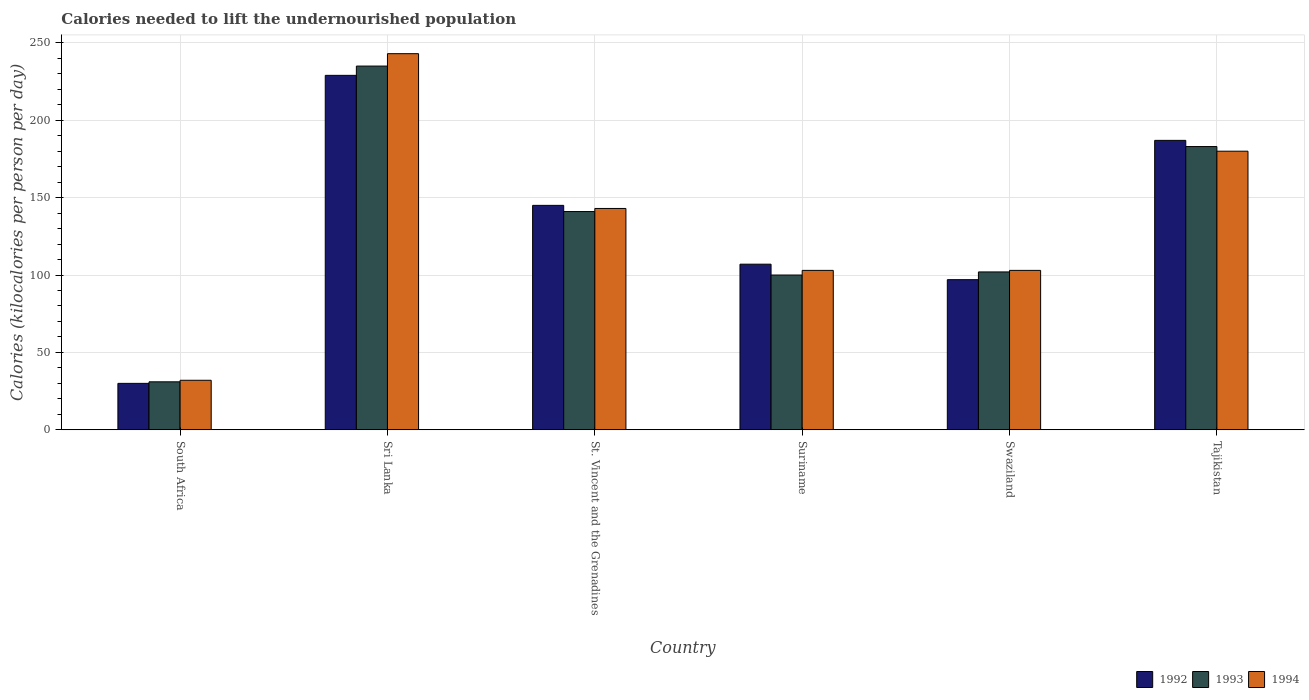How many groups of bars are there?
Your answer should be compact. 6. What is the label of the 5th group of bars from the left?
Provide a succinct answer. Swaziland. In how many cases, is the number of bars for a given country not equal to the number of legend labels?
Your answer should be very brief. 0. What is the total calories needed to lift the undernourished population in 1994 in Sri Lanka?
Give a very brief answer. 243. Across all countries, what is the maximum total calories needed to lift the undernourished population in 1992?
Keep it short and to the point. 229. In which country was the total calories needed to lift the undernourished population in 1994 maximum?
Ensure brevity in your answer.  Sri Lanka. In which country was the total calories needed to lift the undernourished population in 1992 minimum?
Provide a short and direct response. South Africa. What is the total total calories needed to lift the undernourished population in 1992 in the graph?
Provide a succinct answer. 795. What is the difference between the total calories needed to lift the undernourished population in 1994 in Suriname and that in Swaziland?
Your response must be concise. 0. What is the average total calories needed to lift the undernourished population in 1992 per country?
Your answer should be very brief. 132.5. What is the difference between the total calories needed to lift the undernourished population of/in 1994 and total calories needed to lift the undernourished population of/in 1992 in South Africa?
Offer a terse response. 2. What is the ratio of the total calories needed to lift the undernourished population in 1992 in Sri Lanka to that in Tajikistan?
Make the answer very short. 1.22. Is the total calories needed to lift the undernourished population in 1992 in Sri Lanka less than that in Suriname?
Offer a very short reply. No. What is the difference between the highest and the second highest total calories needed to lift the undernourished population in 1993?
Keep it short and to the point. 94. What is the difference between the highest and the lowest total calories needed to lift the undernourished population in 1992?
Provide a short and direct response. 199. In how many countries, is the total calories needed to lift the undernourished population in 1994 greater than the average total calories needed to lift the undernourished population in 1994 taken over all countries?
Your response must be concise. 3. Is the sum of the total calories needed to lift the undernourished population in 1994 in St. Vincent and the Grenadines and Tajikistan greater than the maximum total calories needed to lift the undernourished population in 1993 across all countries?
Keep it short and to the point. Yes. What does the 3rd bar from the right in Tajikistan represents?
Your answer should be very brief. 1992. Is it the case that in every country, the sum of the total calories needed to lift the undernourished population in 1993 and total calories needed to lift the undernourished population in 1992 is greater than the total calories needed to lift the undernourished population in 1994?
Your response must be concise. Yes. How many bars are there?
Your answer should be compact. 18. Are all the bars in the graph horizontal?
Your answer should be compact. No. How many countries are there in the graph?
Your answer should be very brief. 6. What is the difference between two consecutive major ticks on the Y-axis?
Your response must be concise. 50. Does the graph contain any zero values?
Your response must be concise. No. Does the graph contain grids?
Make the answer very short. Yes. Where does the legend appear in the graph?
Keep it short and to the point. Bottom right. How many legend labels are there?
Keep it short and to the point. 3. What is the title of the graph?
Make the answer very short. Calories needed to lift the undernourished population. What is the label or title of the X-axis?
Provide a short and direct response. Country. What is the label or title of the Y-axis?
Offer a very short reply. Calories (kilocalories per person per day). What is the Calories (kilocalories per person per day) in 1993 in South Africa?
Give a very brief answer. 31. What is the Calories (kilocalories per person per day) of 1994 in South Africa?
Offer a very short reply. 32. What is the Calories (kilocalories per person per day) in 1992 in Sri Lanka?
Ensure brevity in your answer.  229. What is the Calories (kilocalories per person per day) of 1993 in Sri Lanka?
Your answer should be very brief. 235. What is the Calories (kilocalories per person per day) in 1994 in Sri Lanka?
Give a very brief answer. 243. What is the Calories (kilocalories per person per day) of 1992 in St. Vincent and the Grenadines?
Provide a short and direct response. 145. What is the Calories (kilocalories per person per day) of 1993 in St. Vincent and the Grenadines?
Keep it short and to the point. 141. What is the Calories (kilocalories per person per day) of 1994 in St. Vincent and the Grenadines?
Provide a short and direct response. 143. What is the Calories (kilocalories per person per day) of 1992 in Suriname?
Provide a short and direct response. 107. What is the Calories (kilocalories per person per day) of 1994 in Suriname?
Keep it short and to the point. 103. What is the Calories (kilocalories per person per day) in 1992 in Swaziland?
Provide a short and direct response. 97. What is the Calories (kilocalories per person per day) of 1993 in Swaziland?
Offer a terse response. 102. What is the Calories (kilocalories per person per day) in 1994 in Swaziland?
Offer a very short reply. 103. What is the Calories (kilocalories per person per day) in 1992 in Tajikistan?
Provide a succinct answer. 187. What is the Calories (kilocalories per person per day) of 1993 in Tajikistan?
Give a very brief answer. 183. What is the Calories (kilocalories per person per day) of 1994 in Tajikistan?
Keep it short and to the point. 180. Across all countries, what is the maximum Calories (kilocalories per person per day) in 1992?
Provide a succinct answer. 229. Across all countries, what is the maximum Calories (kilocalories per person per day) of 1993?
Your answer should be compact. 235. Across all countries, what is the maximum Calories (kilocalories per person per day) in 1994?
Your answer should be very brief. 243. Across all countries, what is the minimum Calories (kilocalories per person per day) of 1992?
Your answer should be compact. 30. Across all countries, what is the minimum Calories (kilocalories per person per day) of 1994?
Your response must be concise. 32. What is the total Calories (kilocalories per person per day) in 1992 in the graph?
Your response must be concise. 795. What is the total Calories (kilocalories per person per day) of 1993 in the graph?
Provide a succinct answer. 792. What is the total Calories (kilocalories per person per day) in 1994 in the graph?
Your answer should be very brief. 804. What is the difference between the Calories (kilocalories per person per day) of 1992 in South Africa and that in Sri Lanka?
Ensure brevity in your answer.  -199. What is the difference between the Calories (kilocalories per person per day) in 1993 in South Africa and that in Sri Lanka?
Keep it short and to the point. -204. What is the difference between the Calories (kilocalories per person per day) in 1994 in South Africa and that in Sri Lanka?
Provide a short and direct response. -211. What is the difference between the Calories (kilocalories per person per day) of 1992 in South Africa and that in St. Vincent and the Grenadines?
Give a very brief answer. -115. What is the difference between the Calories (kilocalories per person per day) in 1993 in South Africa and that in St. Vincent and the Grenadines?
Ensure brevity in your answer.  -110. What is the difference between the Calories (kilocalories per person per day) of 1994 in South Africa and that in St. Vincent and the Grenadines?
Your response must be concise. -111. What is the difference between the Calories (kilocalories per person per day) in 1992 in South Africa and that in Suriname?
Your answer should be very brief. -77. What is the difference between the Calories (kilocalories per person per day) of 1993 in South Africa and that in Suriname?
Provide a succinct answer. -69. What is the difference between the Calories (kilocalories per person per day) in 1994 in South Africa and that in Suriname?
Your answer should be compact. -71. What is the difference between the Calories (kilocalories per person per day) of 1992 in South Africa and that in Swaziland?
Provide a short and direct response. -67. What is the difference between the Calories (kilocalories per person per day) of 1993 in South Africa and that in Swaziland?
Offer a terse response. -71. What is the difference between the Calories (kilocalories per person per day) in 1994 in South Africa and that in Swaziland?
Provide a succinct answer. -71. What is the difference between the Calories (kilocalories per person per day) in 1992 in South Africa and that in Tajikistan?
Make the answer very short. -157. What is the difference between the Calories (kilocalories per person per day) in 1993 in South Africa and that in Tajikistan?
Your answer should be very brief. -152. What is the difference between the Calories (kilocalories per person per day) in 1994 in South Africa and that in Tajikistan?
Provide a succinct answer. -148. What is the difference between the Calories (kilocalories per person per day) in 1992 in Sri Lanka and that in St. Vincent and the Grenadines?
Provide a succinct answer. 84. What is the difference between the Calories (kilocalories per person per day) in 1993 in Sri Lanka and that in St. Vincent and the Grenadines?
Offer a very short reply. 94. What is the difference between the Calories (kilocalories per person per day) in 1994 in Sri Lanka and that in St. Vincent and the Grenadines?
Offer a terse response. 100. What is the difference between the Calories (kilocalories per person per day) in 1992 in Sri Lanka and that in Suriname?
Your response must be concise. 122. What is the difference between the Calories (kilocalories per person per day) of 1993 in Sri Lanka and that in Suriname?
Provide a succinct answer. 135. What is the difference between the Calories (kilocalories per person per day) of 1994 in Sri Lanka and that in Suriname?
Your answer should be very brief. 140. What is the difference between the Calories (kilocalories per person per day) of 1992 in Sri Lanka and that in Swaziland?
Offer a very short reply. 132. What is the difference between the Calories (kilocalories per person per day) in 1993 in Sri Lanka and that in Swaziland?
Make the answer very short. 133. What is the difference between the Calories (kilocalories per person per day) of 1994 in Sri Lanka and that in Swaziland?
Your answer should be very brief. 140. What is the difference between the Calories (kilocalories per person per day) of 1993 in Sri Lanka and that in Tajikistan?
Ensure brevity in your answer.  52. What is the difference between the Calories (kilocalories per person per day) of 1994 in St. Vincent and the Grenadines and that in Suriname?
Provide a short and direct response. 40. What is the difference between the Calories (kilocalories per person per day) in 1992 in St. Vincent and the Grenadines and that in Swaziland?
Your answer should be compact. 48. What is the difference between the Calories (kilocalories per person per day) in 1993 in St. Vincent and the Grenadines and that in Swaziland?
Make the answer very short. 39. What is the difference between the Calories (kilocalories per person per day) in 1992 in St. Vincent and the Grenadines and that in Tajikistan?
Offer a very short reply. -42. What is the difference between the Calories (kilocalories per person per day) in 1993 in St. Vincent and the Grenadines and that in Tajikistan?
Your answer should be compact. -42. What is the difference between the Calories (kilocalories per person per day) of 1994 in St. Vincent and the Grenadines and that in Tajikistan?
Make the answer very short. -37. What is the difference between the Calories (kilocalories per person per day) of 1993 in Suriname and that in Swaziland?
Make the answer very short. -2. What is the difference between the Calories (kilocalories per person per day) of 1992 in Suriname and that in Tajikistan?
Offer a very short reply. -80. What is the difference between the Calories (kilocalories per person per day) of 1993 in Suriname and that in Tajikistan?
Ensure brevity in your answer.  -83. What is the difference between the Calories (kilocalories per person per day) in 1994 in Suriname and that in Tajikistan?
Your answer should be compact. -77. What is the difference between the Calories (kilocalories per person per day) of 1992 in Swaziland and that in Tajikistan?
Give a very brief answer. -90. What is the difference between the Calories (kilocalories per person per day) of 1993 in Swaziland and that in Tajikistan?
Your answer should be compact. -81. What is the difference between the Calories (kilocalories per person per day) in 1994 in Swaziland and that in Tajikistan?
Offer a terse response. -77. What is the difference between the Calories (kilocalories per person per day) of 1992 in South Africa and the Calories (kilocalories per person per day) of 1993 in Sri Lanka?
Your response must be concise. -205. What is the difference between the Calories (kilocalories per person per day) of 1992 in South Africa and the Calories (kilocalories per person per day) of 1994 in Sri Lanka?
Make the answer very short. -213. What is the difference between the Calories (kilocalories per person per day) of 1993 in South Africa and the Calories (kilocalories per person per day) of 1994 in Sri Lanka?
Ensure brevity in your answer.  -212. What is the difference between the Calories (kilocalories per person per day) of 1992 in South Africa and the Calories (kilocalories per person per day) of 1993 in St. Vincent and the Grenadines?
Provide a short and direct response. -111. What is the difference between the Calories (kilocalories per person per day) in 1992 in South Africa and the Calories (kilocalories per person per day) in 1994 in St. Vincent and the Grenadines?
Provide a short and direct response. -113. What is the difference between the Calories (kilocalories per person per day) in 1993 in South Africa and the Calories (kilocalories per person per day) in 1994 in St. Vincent and the Grenadines?
Offer a terse response. -112. What is the difference between the Calories (kilocalories per person per day) of 1992 in South Africa and the Calories (kilocalories per person per day) of 1993 in Suriname?
Provide a short and direct response. -70. What is the difference between the Calories (kilocalories per person per day) of 1992 in South Africa and the Calories (kilocalories per person per day) of 1994 in Suriname?
Provide a short and direct response. -73. What is the difference between the Calories (kilocalories per person per day) of 1993 in South Africa and the Calories (kilocalories per person per day) of 1994 in Suriname?
Your answer should be compact. -72. What is the difference between the Calories (kilocalories per person per day) of 1992 in South Africa and the Calories (kilocalories per person per day) of 1993 in Swaziland?
Your answer should be compact. -72. What is the difference between the Calories (kilocalories per person per day) in 1992 in South Africa and the Calories (kilocalories per person per day) in 1994 in Swaziland?
Give a very brief answer. -73. What is the difference between the Calories (kilocalories per person per day) of 1993 in South Africa and the Calories (kilocalories per person per day) of 1994 in Swaziland?
Offer a very short reply. -72. What is the difference between the Calories (kilocalories per person per day) in 1992 in South Africa and the Calories (kilocalories per person per day) in 1993 in Tajikistan?
Your answer should be compact. -153. What is the difference between the Calories (kilocalories per person per day) of 1992 in South Africa and the Calories (kilocalories per person per day) of 1994 in Tajikistan?
Keep it short and to the point. -150. What is the difference between the Calories (kilocalories per person per day) of 1993 in South Africa and the Calories (kilocalories per person per day) of 1994 in Tajikistan?
Give a very brief answer. -149. What is the difference between the Calories (kilocalories per person per day) in 1992 in Sri Lanka and the Calories (kilocalories per person per day) in 1993 in St. Vincent and the Grenadines?
Offer a very short reply. 88. What is the difference between the Calories (kilocalories per person per day) of 1993 in Sri Lanka and the Calories (kilocalories per person per day) of 1994 in St. Vincent and the Grenadines?
Offer a very short reply. 92. What is the difference between the Calories (kilocalories per person per day) of 1992 in Sri Lanka and the Calories (kilocalories per person per day) of 1993 in Suriname?
Offer a terse response. 129. What is the difference between the Calories (kilocalories per person per day) in 1992 in Sri Lanka and the Calories (kilocalories per person per day) in 1994 in Suriname?
Your answer should be compact. 126. What is the difference between the Calories (kilocalories per person per day) of 1993 in Sri Lanka and the Calories (kilocalories per person per day) of 1994 in Suriname?
Give a very brief answer. 132. What is the difference between the Calories (kilocalories per person per day) of 1992 in Sri Lanka and the Calories (kilocalories per person per day) of 1993 in Swaziland?
Provide a succinct answer. 127. What is the difference between the Calories (kilocalories per person per day) of 1992 in Sri Lanka and the Calories (kilocalories per person per day) of 1994 in Swaziland?
Keep it short and to the point. 126. What is the difference between the Calories (kilocalories per person per day) in 1993 in Sri Lanka and the Calories (kilocalories per person per day) in 1994 in Swaziland?
Provide a short and direct response. 132. What is the difference between the Calories (kilocalories per person per day) in 1993 in Sri Lanka and the Calories (kilocalories per person per day) in 1994 in Tajikistan?
Your response must be concise. 55. What is the difference between the Calories (kilocalories per person per day) of 1993 in St. Vincent and the Grenadines and the Calories (kilocalories per person per day) of 1994 in Suriname?
Your answer should be compact. 38. What is the difference between the Calories (kilocalories per person per day) in 1992 in St. Vincent and the Grenadines and the Calories (kilocalories per person per day) in 1993 in Swaziland?
Your answer should be very brief. 43. What is the difference between the Calories (kilocalories per person per day) in 1993 in St. Vincent and the Grenadines and the Calories (kilocalories per person per day) in 1994 in Swaziland?
Make the answer very short. 38. What is the difference between the Calories (kilocalories per person per day) of 1992 in St. Vincent and the Grenadines and the Calories (kilocalories per person per day) of 1993 in Tajikistan?
Make the answer very short. -38. What is the difference between the Calories (kilocalories per person per day) of 1992 in St. Vincent and the Grenadines and the Calories (kilocalories per person per day) of 1994 in Tajikistan?
Ensure brevity in your answer.  -35. What is the difference between the Calories (kilocalories per person per day) in 1993 in St. Vincent and the Grenadines and the Calories (kilocalories per person per day) in 1994 in Tajikistan?
Your response must be concise. -39. What is the difference between the Calories (kilocalories per person per day) in 1992 in Suriname and the Calories (kilocalories per person per day) in 1993 in Swaziland?
Provide a short and direct response. 5. What is the difference between the Calories (kilocalories per person per day) of 1992 in Suriname and the Calories (kilocalories per person per day) of 1994 in Swaziland?
Provide a short and direct response. 4. What is the difference between the Calories (kilocalories per person per day) of 1992 in Suriname and the Calories (kilocalories per person per day) of 1993 in Tajikistan?
Offer a very short reply. -76. What is the difference between the Calories (kilocalories per person per day) of 1992 in Suriname and the Calories (kilocalories per person per day) of 1994 in Tajikistan?
Ensure brevity in your answer.  -73. What is the difference between the Calories (kilocalories per person per day) of 1993 in Suriname and the Calories (kilocalories per person per day) of 1994 in Tajikistan?
Your response must be concise. -80. What is the difference between the Calories (kilocalories per person per day) in 1992 in Swaziland and the Calories (kilocalories per person per day) in 1993 in Tajikistan?
Provide a short and direct response. -86. What is the difference between the Calories (kilocalories per person per day) in 1992 in Swaziland and the Calories (kilocalories per person per day) in 1994 in Tajikistan?
Your answer should be compact. -83. What is the difference between the Calories (kilocalories per person per day) in 1993 in Swaziland and the Calories (kilocalories per person per day) in 1994 in Tajikistan?
Ensure brevity in your answer.  -78. What is the average Calories (kilocalories per person per day) of 1992 per country?
Your answer should be very brief. 132.5. What is the average Calories (kilocalories per person per day) in 1993 per country?
Ensure brevity in your answer.  132. What is the average Calories (kilocalories per person per day) in 1994 per country?
Give a very brief answer. 134. What is the difference between the Calories (kilocalories per person per day) in 1992 and Calories (kilocalories per person per day) in 1993 in South Africa?
Your response must be concise. -1. What is the difference between the Calories (kilocalories per person per day) in 1992 and Calories (kilocalories per person per day) in 1994 in South Africa?
Your answer should be compact. -2. What is the difference between the Calories (kilocalories per person per day) in 1993 and Calories (kilocalories per person per day) in 1994 in South Africa?
Your answer should be very brief. -1. What is the difference between the Calories (kilocalories per person per day) of 1992 and Calories (kilocalories per person per day) of 1993 in Sri Lanka?
Provide a short and direct response. -6. What is the difference between the Calories (kilocalories per person per day) of 1993 and Calories (kilocalories per person per day) of 1994 in Sri Lanka?
Offer a terse response. -8. What is the difference between the Calories (kilocalories per person per day) in 1992 and Calories (kilocalories per person per day) in 1994 in St. Vincent and the Grenadines?
Your response must be concise. 2. What is the difference between the Calories (kilocalories per person per day) in 1993 and Calories (kilocalories per person per day) in 1994 in St. Vincent and the Grenadines?
Provide a succinct answer. -2. What is the difference between the Calories (kilocalories per person per day) in 1992 and Calories (kilocalories per person per day) in 1994 in Suriname?
Give a very brief answer. 4. What is the difference between the Calories (kilocalories per person per day) in 1992 and Calories (kilocalories per person per day) in 1994 in Swaziland?
Keep it short and to the point. -6. What is the difference between the Calories (kilocalories per person per day) of 1993 and Calories (kilocalories per person per day) of 1994 in Swaziland?
Keep it short and to the point. -1. What is the difference between the Calories (kilocalories per person per day) of 1992 and Calories (kilocalories per person per day) of 1993 in Tajikistan?
Your answer should be very brief. 4. What is the difference between the Calories (kilocalories per person per day) in 1992 and Calories (kilocalories per person per day) in 1994 in Tajikistan?
Offer a very short reply. 7. What is the difference between the Calories (kilocalories per person per day) in 1993 and Calories (kilocalories per person per day) in 1994 in Tajikistan?
Make the answer very short. 3. What is the ratio of the Calories (kilocalories per person per day) in 1992 in South Africa to that in Sri Lanka?
Give a very brief answer. 0.13. What is the ratio of the Calories (kilocalories per person per day) in 1993 in South Africa to that in Sri Lanka?
Offer a terse response. 0.13. What is the ratio of the Calories (kilocalories per person per day) in 1994 in South Africa to that in Sri Lanka?
Your answer should be compact. 0.13. What is the ratio of the Calories (kilocalories per person per day) of 1992 in South Africa to that in St. Vincent and the Grenadines?
Your response must be concise. 0.21. What is the ratio of the Calories (kilocalories per person per day) in 1993 in South Africa to that in St. Vincent and the Grenadines?
Ensure brevity in your answer.  0.22. What is the ratio of the Calories (kilocalories per person per day) of 1994 in South Africa to that in St. Vincent and the Grenadines?
Your answer should be very brief. 0.22. What is the ratio of the Calories (kilocalories per person per day) in 1992 in South Africa to that in Suriname?
Offer a terse response. 0.28. What is the ratio of the Calories (kilocalories per person per day) of 1993 in South Africa to that in Suriname?
Keep it short and to the point. 0.31. What is the ratio of the Calories (kilocalories per person per day) in 1994 in South Africa to that in Suriname?
Make the answer very short. 0.31. What is the ratio of the Calories (kilocalories per person per day) in 1992 in South Africa to that in Swaziland?
Keep it short and to the point. 0.31. What is the ratio of the Calories (kilocalories per person per day) in 1993 in South Africa to that in Swaziland?
Your response must be concise. 0.3. What is the ratio of the Calories (kilocalories per person per day) in 1994 in South Africa to that in Swaziland?
Make the answer very short. 0.31. What is the ratio of the Calories (kilocalories per person per day) in 1992 in South Africa to that in Tajikistan?
Keep it short and to the point. 0.16. What is the ratio of the Calories (kilocalories per person per day) in 1993 in South Africa to that in Tajikistan?
Ensure brevity in your answer.  0.17. What is the ratio of the Calories (kilocalories per person per day) in 1994 in South Africa to that in Tajikistan?
Keep it short and to the point. 0.18. What is the ratio of the Calories (kilocalories per person per day) of 1992 in Sri Lanka to that in St. Vincent and the Grenadines?
Your response must be concise. 1.58. What is the ratio of the Calories (kilocalories per person per day) in 1993 in Sri Lanka to that in St. Vincent and the Grenadines?
Your answer should be compact. 1.67. What is the ratio of the Calories (kilocalories per person per day) of 1994 in Sri Lanka to that in St. Vincent and the Grenadines?
Offer a very short reply. 1.7. What is the ratio of the Calories (kilocalories per person per day) of 1992 in Sri Lanka to that in Suriname?
Give a very brief answer. 2.14. What is the ratio of the Calories (kilocalories per person per day) of 1993 in Sri Lanka to that in Suriname?
Ensure brevity in your answer.  2.35. What is the ratio of the Calories (kilocalories per person per day) of 1994 in Sri Lanka to that in Suriname?
Keep it short and to the point. 2.36. What is the ratio of the Calories (kilocalories per person per day) of 1992 in Sri Lanka to that in Swaziland?
Ensure brevity in your answer.  2.36. What is the ratio of the Calories (kilocalories per person per day) in 1993 in Sri Lanka to that in Swaziland?
Provide a succinct answer. 2.3. What is the ratio of the Calories (kilocalories per person per day) of 1994 in Sri Lanka to that in Swaziland?
Give a very brief answer. 2.36. What is the ratio of the Calories (kilocalories per person per day) in 1992 in Sri Lanka to that in Tajikistan?
Your answer should be compact. 1.22. What is the ratio of the Calories (kilocalories per person per day) of 1993 in Sri Lanka to that in Tajikistan?
Offer a terse response. 1.28. What is the ratio of the Calories (kilocalories per person per day) of 1994 in Sri Lanka to that in Tajikistan?
Ensure brevity in your answer.  1.35. What is the ratio of the Calories (kilocalories per person per day) of 1992 in St. Vincent and the Grenadines to that in Suriname?
Offer a very short reply. 1.36. What is the ratio of the Calories (kilocalories per person per day) in 1993 in St. Vincent and the Grenadines to that in Suriname?
Offer a very short reply. 1.41. What is the ratio of the Calories (kilocalories per person per day) of 1994 in St. Vincent and the Grenadines to that in Suriname?
Make the answer very short. 1.39. What is the ratio of the Calories (kilocalories per person per day) in 1992 in St. Vincent and the Grenadines to that in Swaziland?
Your answer should be compact. 1.49. What is the ratio of the Calories (kilocalories per person per day) of 1993 in St. Vincent and the Grenadines to that in Swaziland?
Keep it short and to the point. 1.38. What is the ratio of the Calories (kilocalories per person per day) in 1994 in St. Vincent and the Grenadines to that in Swaziland?
Provide a succinct answer. 1.39. What is the ratio of the Calories (kilocalories per person per day) in 1992 in St. Vincent and the Grenadines to that in Tajikistan?
Ensure brevity in your answer.  0.78. What is the ratio of the Calories (kilocalories per person per day) in 1993 in St. Vincent and the Grenadines to that in Tajikistan?
Make the answer very short. 0.77. What is the ratio of the Calories (kilocalories per person per day) in 1994 in St. Vincent and the Grenadines to that in Tajikistan?
Offer a very short reply. 0.79. What is the ratio of the Calories (kilocalories per person per day) of 1992 in Suriname to that in Swaziland?
Your answer should be compact. 1.1. What is the ratio of the Calories (kilocalories per person per day) in 1993 in Suriname to that in Swaziland?
Make the answer very short. 0.98. What is the ratio of the Calories (kilocalories per person per day) in 1994 in Suriname to that in Swaziland?
Make the answer very short. 1. What is the ratio of the Calories (kilocalories per person per day) in 1992 in Suriname to that in Tajikistan?
Keep it short and to the point. 0.57. What is the ratio of the Calories (kilocalories per person per day) of 1993 in Suriname to that in Tajikistan?
Provide a short and direct response. 0.55. What is the ratio of the Calories (kilocalories per person per day) in 1994 in Suriname to that in Tajikistan?
Provide a succinct answer. 0.57. What is the ratio of the Calories (kilocalories per person per day) of 1992 in Swaziland to that in Tajikistan?
Provide a short and direct response. 0.52. What is the ratio of the Calories (kilocalories per person per day) in 1993 in Swaziland to that in Tajikistan?
Your answer should be compact. 0.56. What is the ratio of the Calories (kilocalories per person per day) in 1994 in Swaziland to that in Tajikistan?
Offer a terse response. 0.57. What is the difference between the highest and the second highest Calories (kilocalories per person per day) in 1992?
Provide a succinct answer. 42. What is the difference between the highest and the second highest Calories (kilocalories per person per day) in 1993?
Ensure brevity in your answer.  52. What is the difference between the highest and the lowest Calories (kilocalories per person per day) in 1992?
Provide a succinct answer. 199. What is the difference between the highest and the lowest Calories (kilocalories per person per day) of 1993?
Provide a short and direct response. 204. What is the difference between the highest and the lowest Calories (kilocalories per person per day) of 1994?
Offer a very short reply. 211. 